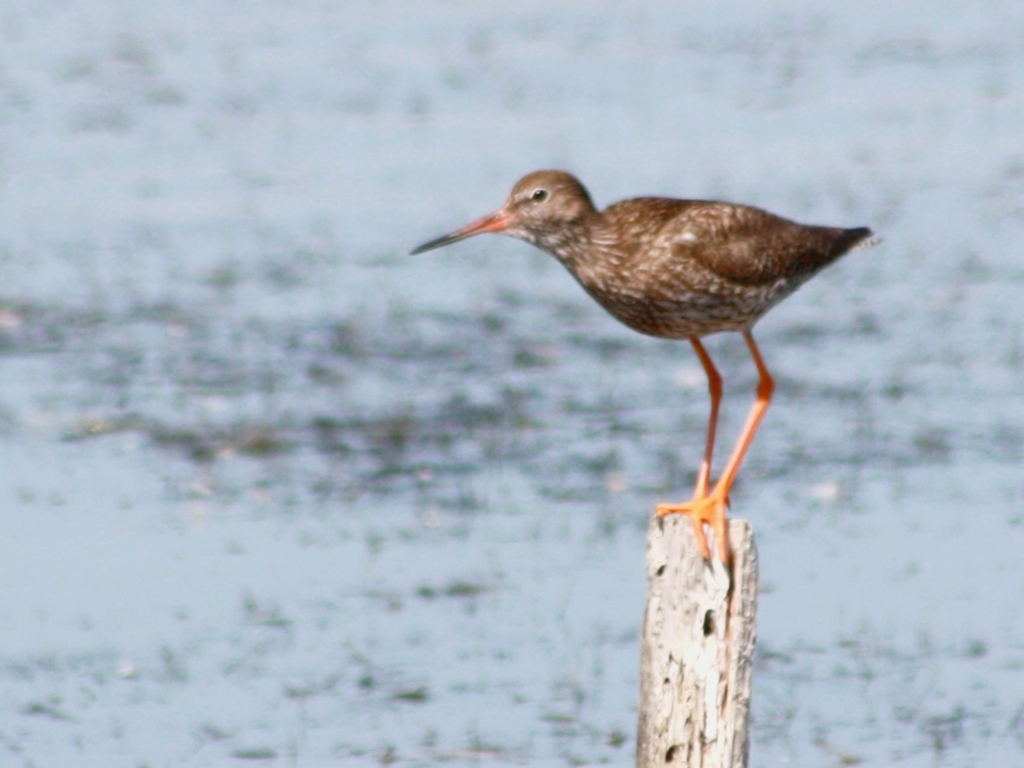What time of day and season do you think this photo was taken, based on the lighting and environment? Judging by the lighting in the photo, it seems to be taken during daylight with bright sunlight, possibly indicating late morning or early afternoon when the sun is high. The glare on the water surface and the harsh shadow cast by the bird suggests strong sunlight. Seasonally, it's challenging to determine without additional context, but the bird's presence and the fact that it's standing on a post in water might suggest a warmer season, perhaps spring or summer, when migratory birds are more likely to be found in such environments.  Is there any indication of human activity or presence in this habitat? There isn't a clear indication of direct human activity in the immediate vicinity of the bird—the natural setting of water and the wooden pole gives the impression of a relatively undisturbed habitat. However, the presence of a man-made object like the wooden post can suggest there is some level of human interaction with this environment, possibly for monitoring purposes or as part of a structure from a dock or walkway. 